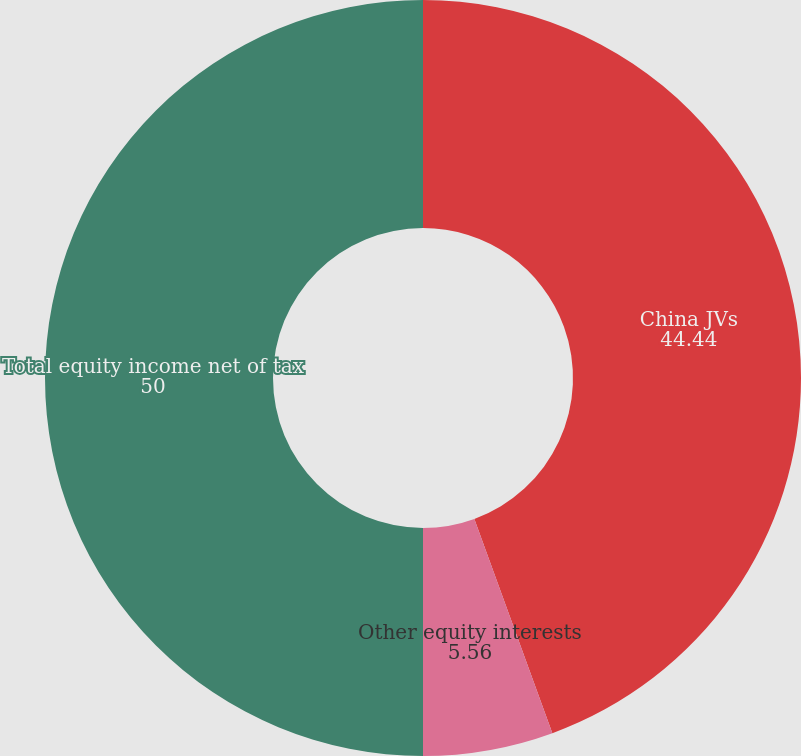Convert chart. <chart><loc_0><loc_0><loc_500><loc_500><pie_chart><fcel>China JVs<fcel>Other equity interests<fcel>Total equity income net of tax<nl><fcel>44.44%<fcel>5.56%<fcel>50.0%<nl></chart> 